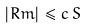<formula> <loc_0><loc_0><loc_500><loc_500>\left | R m \right | \leq c \, S</formula> 